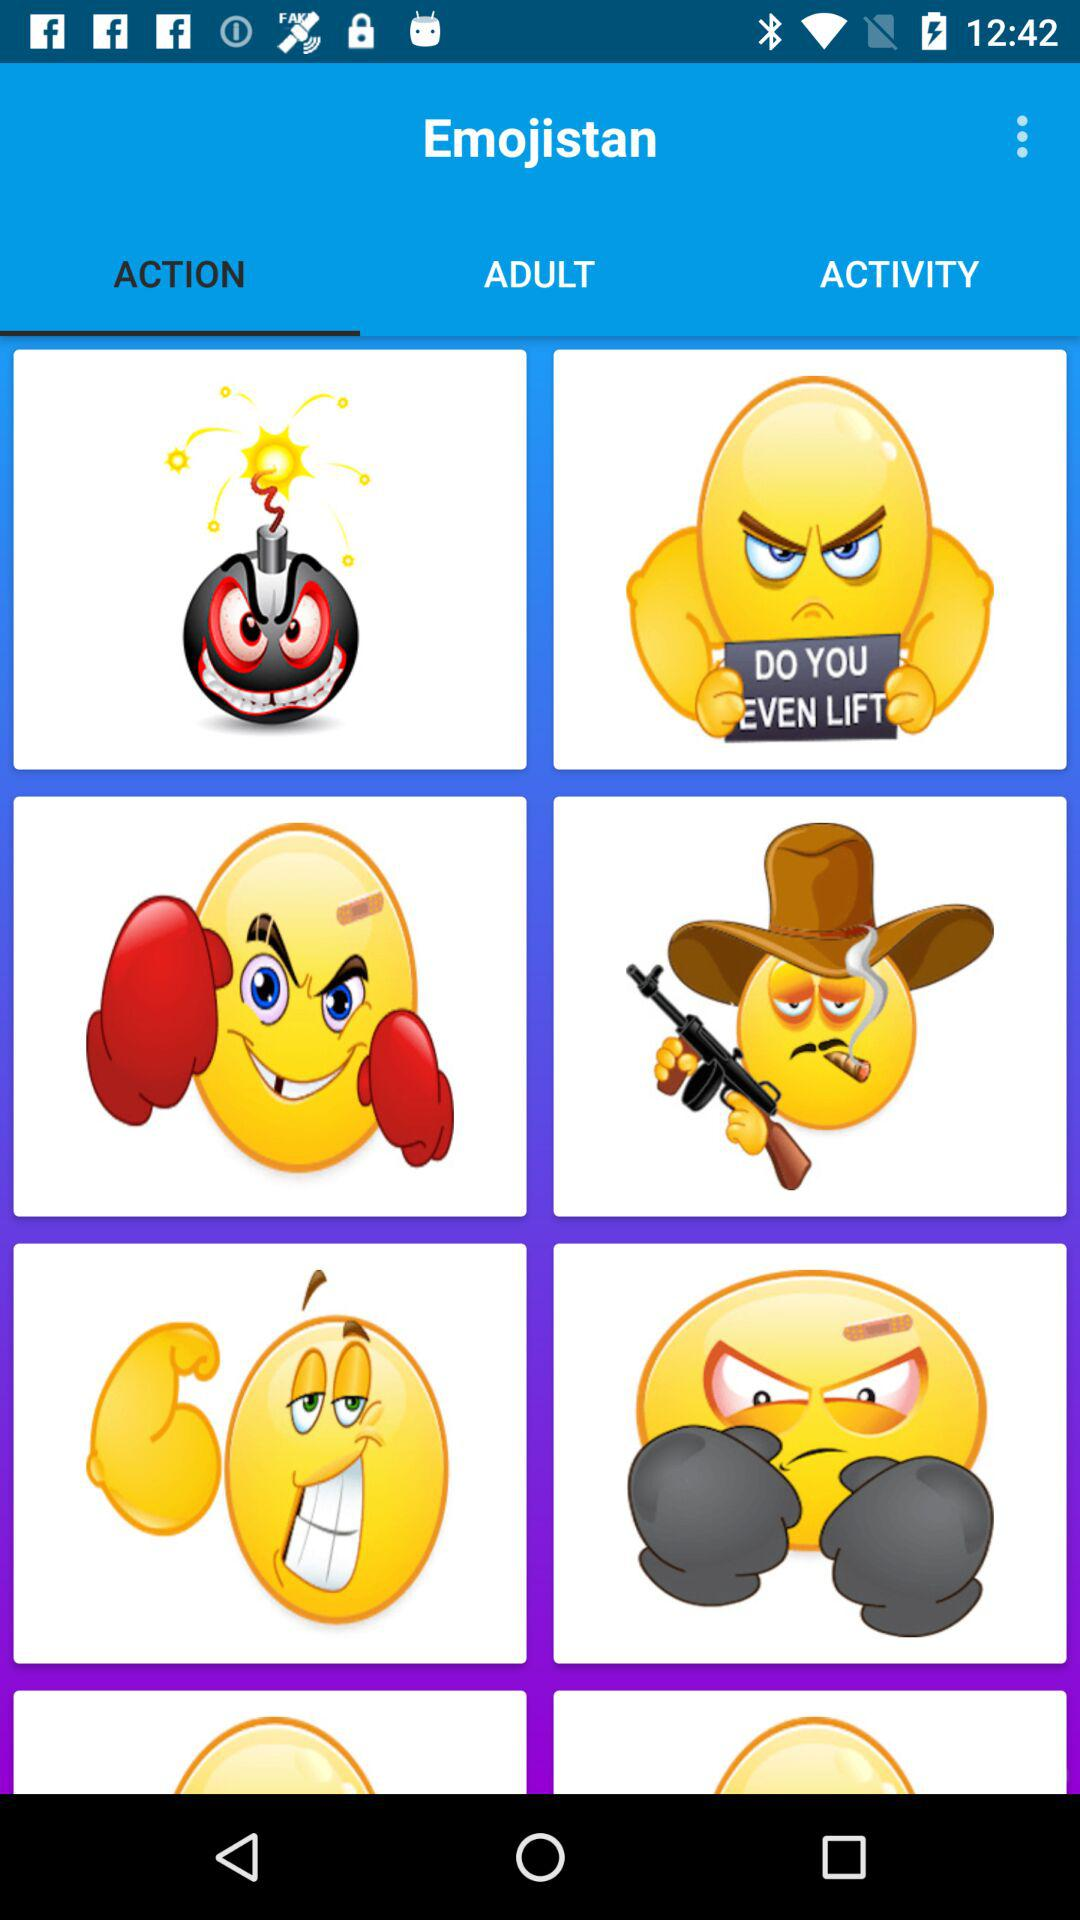What is the name of the application? The name of the application is "Emojistan". 